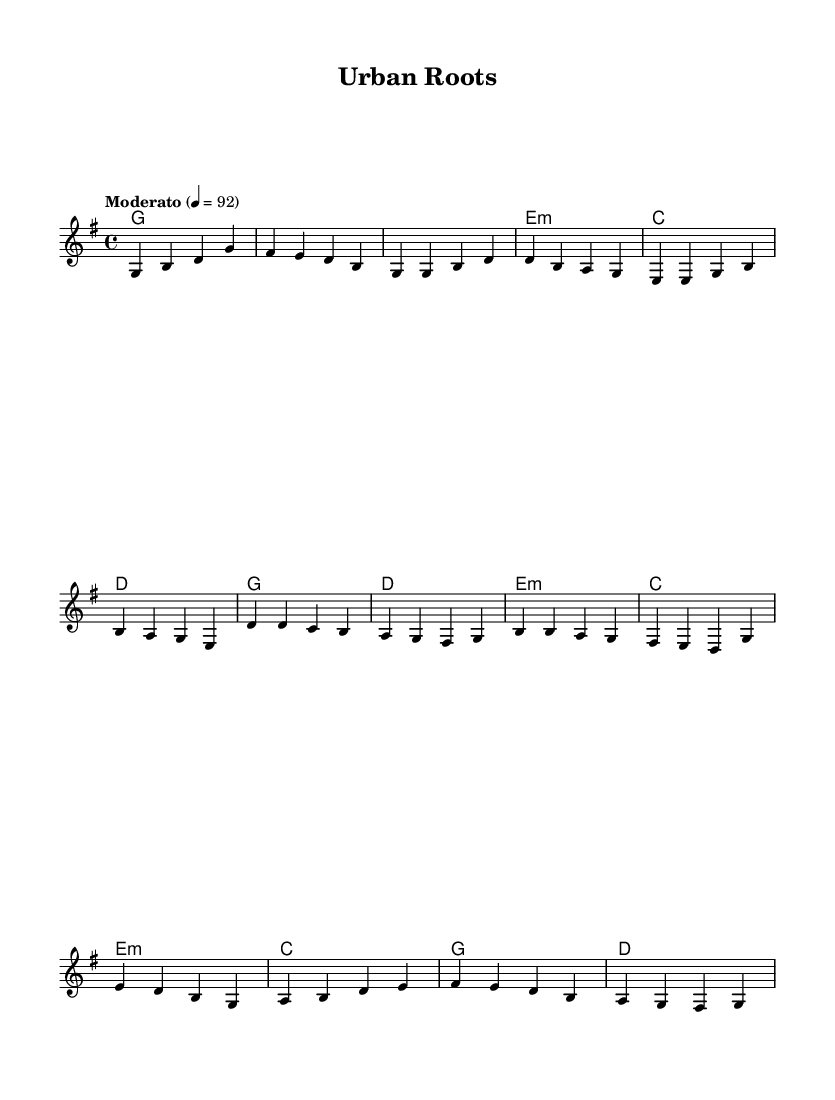What is the key signature of this music? The key signature indicates that there is one sharp, which means the piece is in G major. The presence of an F sharp can be confirmed by looking at the staff.
Answer: G major What is the time signature of this music? The time signature is found at the beginning of the staff and indicates the number of beats in each measure. Here it shows 4/4, meaning there are four beats per measure.
Answer: 4/4 What is the tempo marking for this piece? The tempo marking indicates how fast the music should be played. It is given in beats per minute; in this case, it is set as Moderato at quarter note = 92.
Answer: Moderato 92 How many measures are in the chorus section? To find this, I count the measures in the chorus part of the score, which consists of four distinct measures defined by the bar lines.
Answer: 4 What is the harmonic structure in the verse section? Analyzing the chord symbols listed below the staff for the verse shows the sequence of G, E minor, C, and D, indicating this is the harmonic progression used in that section.
Answer: G, E minor, C, D What type of folk elements are present in the melody? The melody implies simplicity and storytelling commonly found in folk music, characterized by its straightforward intervals and accessible range, which reflects the rural simplicity theme.
Answer: Simplicity, storytelling What is the role of the bridge in this piece? The bridge serves as a contrasting section that provides emotional relief and development, shifting the harmonic focus and adding interest before returning to the main themes.
Answer: Contrast, emotional relief 